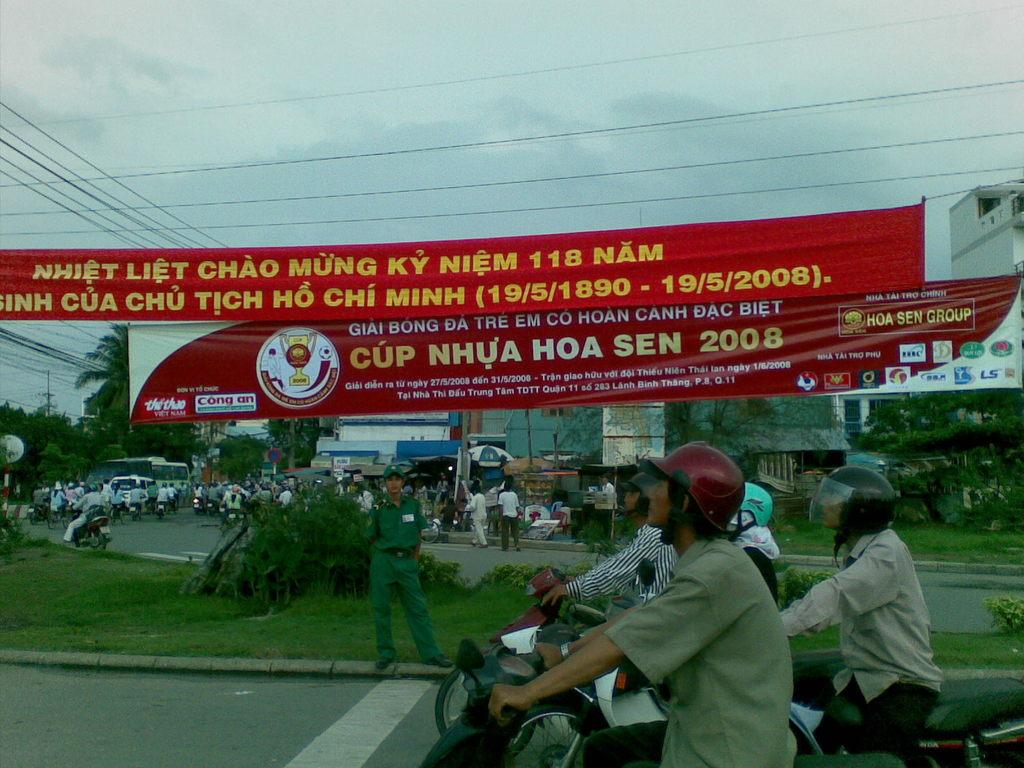What are the people riding in the image? There are bikes on the road, and people are sitting on the bikes. What can be seen hanging or displayed in the image? There are banners in the image. What type of natural environment is visible in the image? Grass and trees are present in the image. What type of structures can be seen in the background of the image? Buildings are in the background of the image. What type of utility infrastructure is present in the image? Wires are present in the image. What else is visible in the image besides the bikes and people? There are some objects in the image. What is visible in the background of the sky? The sky is visible in the background of the image. Is there a volcano erupting in the background of the image? No, there is no volcano present in the image. How deep is the water visible in the image? There is no water visible in the image. 